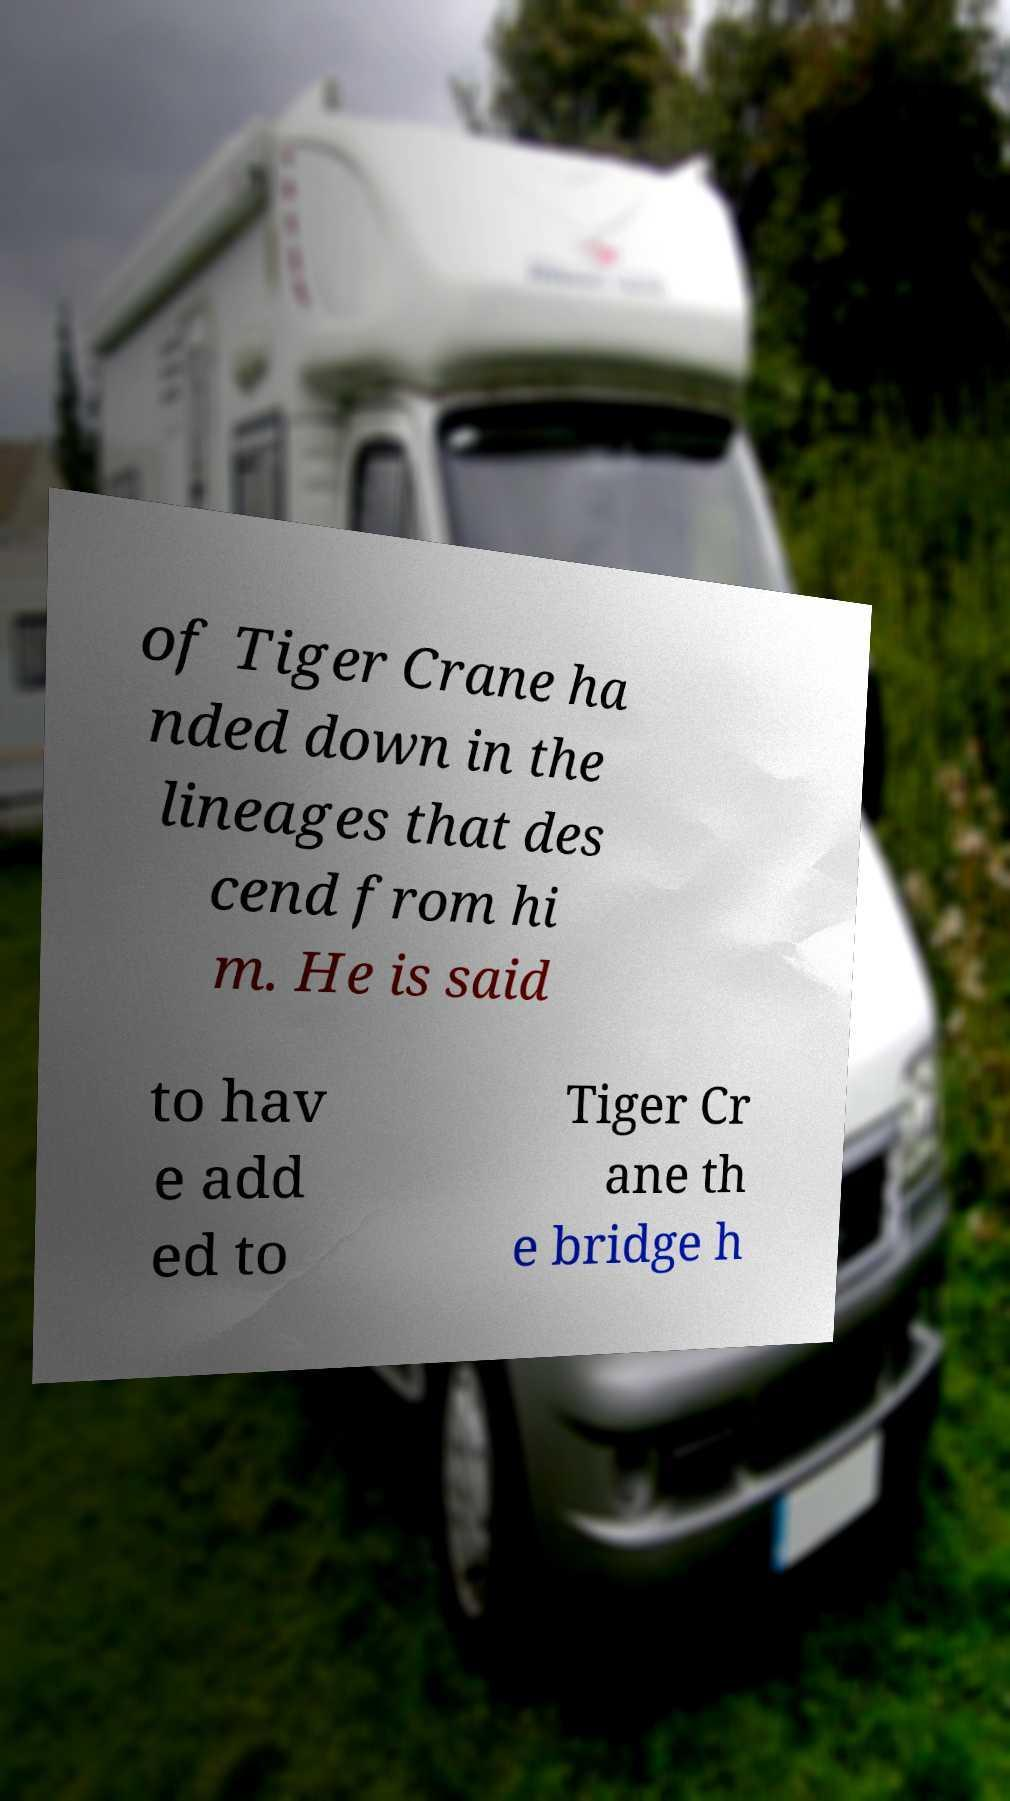Can you read and provide the text displayed in the image?This photo seems to have some interesting text. Can you extract and type it out for me? of Tiger Crane ha nded down in the lineages that des cend from hi m. He is said to hav e add ed to Tiger Cr ane th e bridge h 